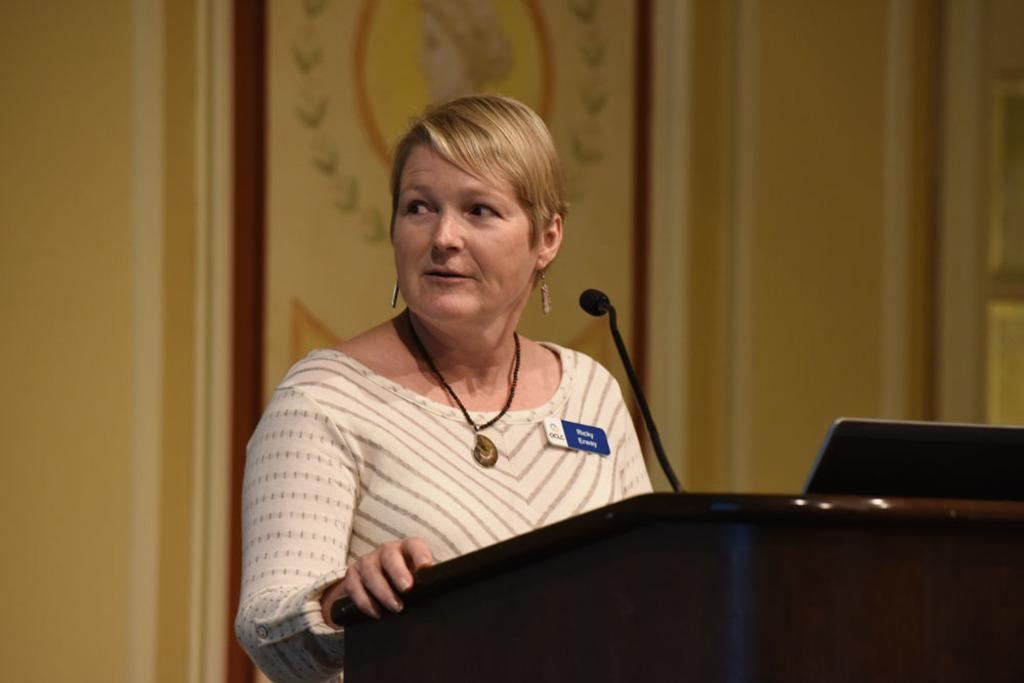Who is the main subject in the image? There is a woman in the image. What is the woman doing in the image? The woman is standing behind a podium. What tools or equipment is the woman using in the image? There is a microphone and a laptop in front of the woman. What can be seen in the background of the image? There is a wall in the background of the image. What type of account is the woman managing in the image? There is no indication in the image that the woman is managing any accounts. 